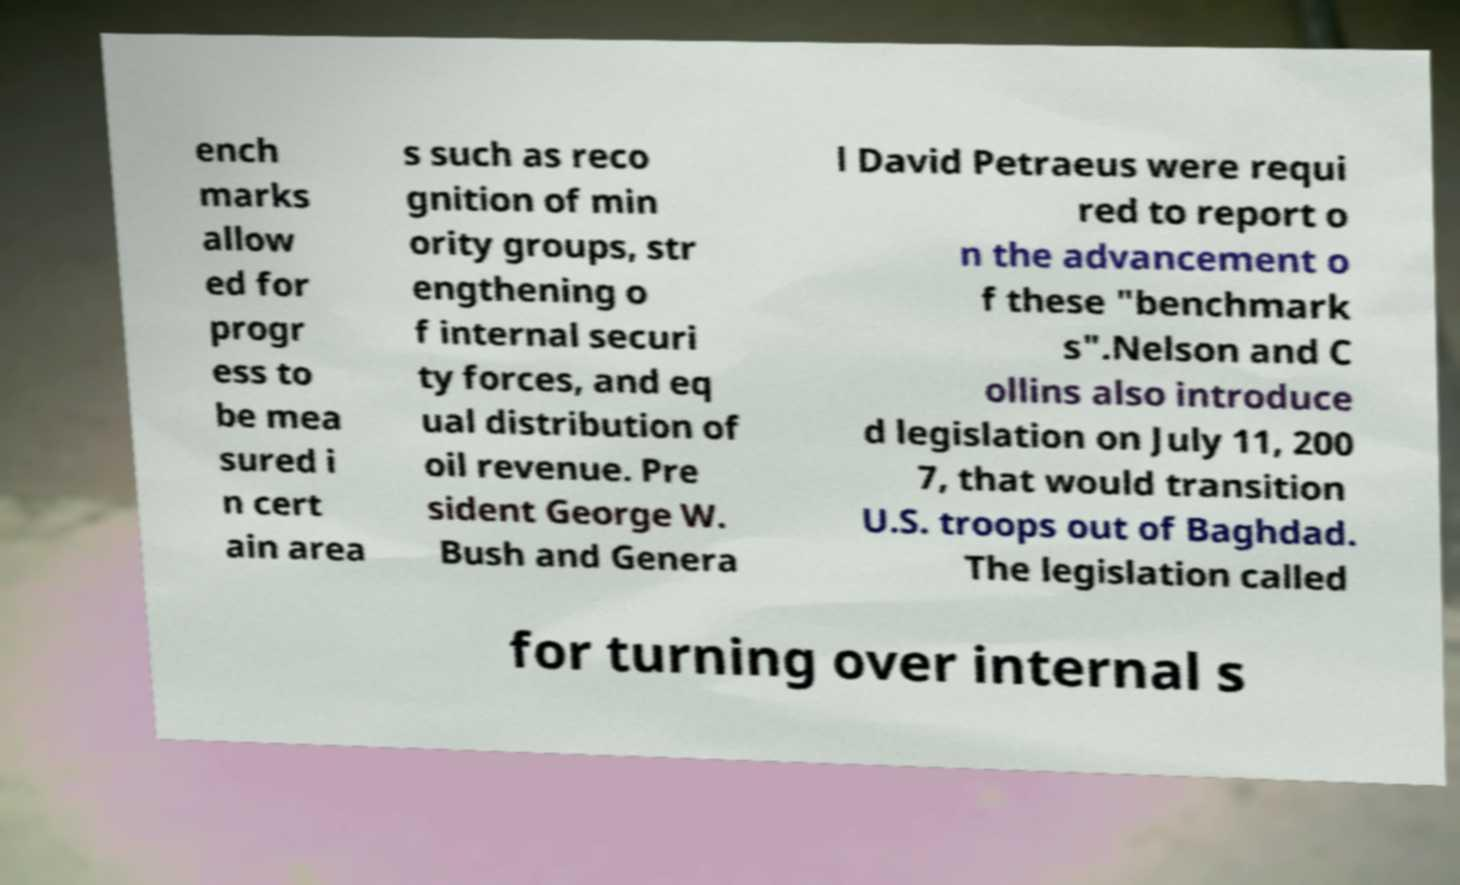For documentation purposes, I need the text within this image transcribed. Could you provide that? ench marks allow ed for progr ess to be mea sured i n cert ain area s such as reco gnition of min ority groups, str engthening o f internal securi ty forces, and eq ual distribution of oil revenue. Pre sident George W. Bush and Genera l David Petraeus were requi red to report o n the advancement o f these "benchmark s".Nelson and C ollins also introduce d legislation on July 11, 200 7, that would transition U.S. troops out of Baghdad. The legislation called for turning over internal s 